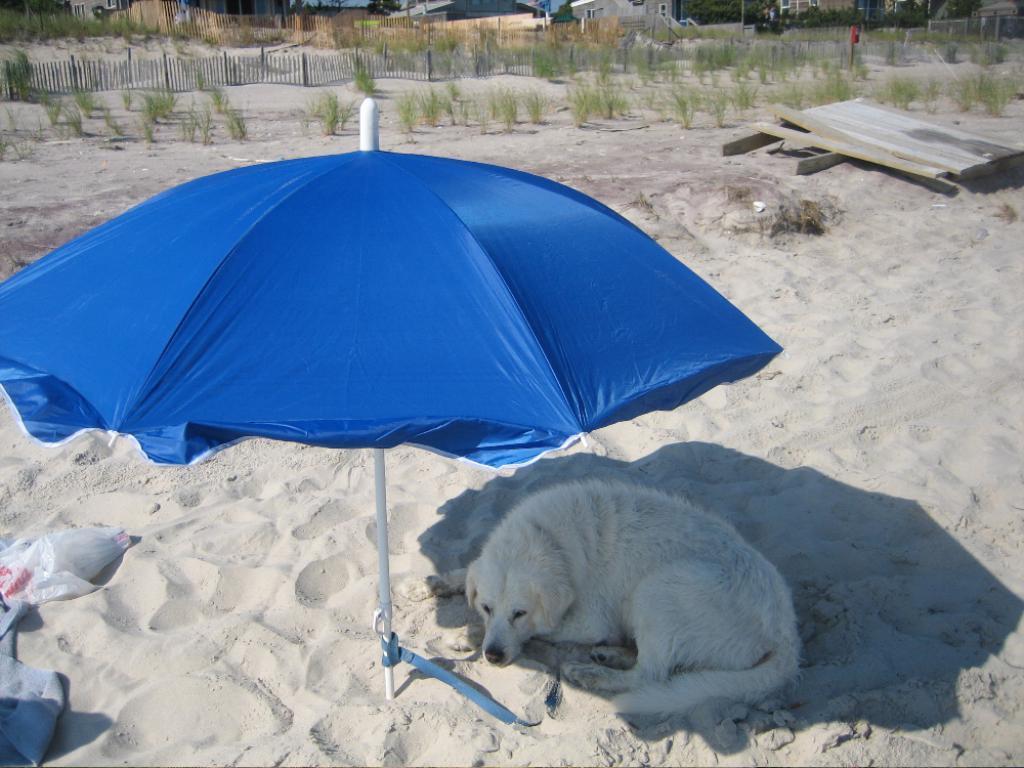How would you summarize this image in a sentence or two? This image consists of a dog sleeping on the ground. At the bottom, there is sand. In the front, there is an umbrella in blue color. In the background, there are small plants and fencing. 